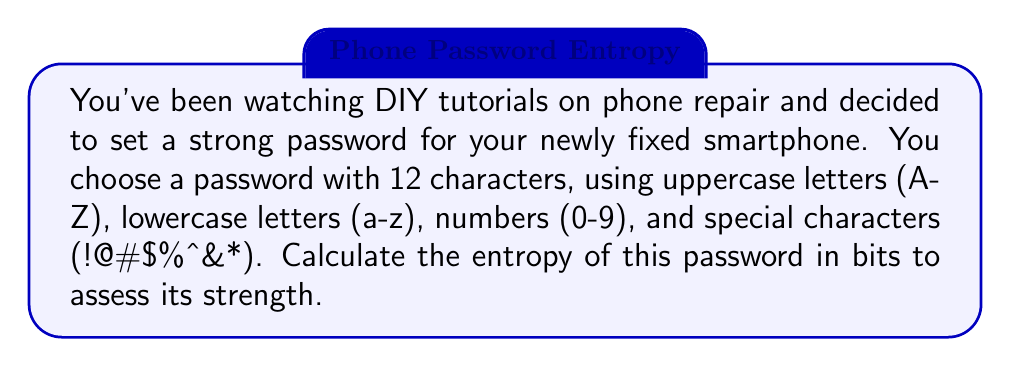Could you help me with this problem? To calculate the entropy of a password, we use the formula:

$$E = L \times \log_2(R)$$

Where:
$E$ = entropy in bits
$L$ = length of the password
$R$ = size of the character set (pool of possible characters)

Step 1: Determine the length of the password (L)
$L = 12$ characters

Step 2: Calculate the size of the character set (R)
- Uppercase letters: 26
- Lowercase letters: 26
- Numbers: 10
- Special characters: 8
Total: $R = 26 + 26 + 10 + 8 = 70$ possible characters

Step 3: Apply the formula
$$E = 12 \times \log_2(70)$$

Step 4: Calculate $\log_2(70)$
$\log_2(70) \approx 6.129$

Step 5: Multiply by the password length
$$E = 12 \times 6.129 \approx 73.55$$

Therefore, the entropy of the password is approximately 73.55 bits.
Answer: 73.55 bits 